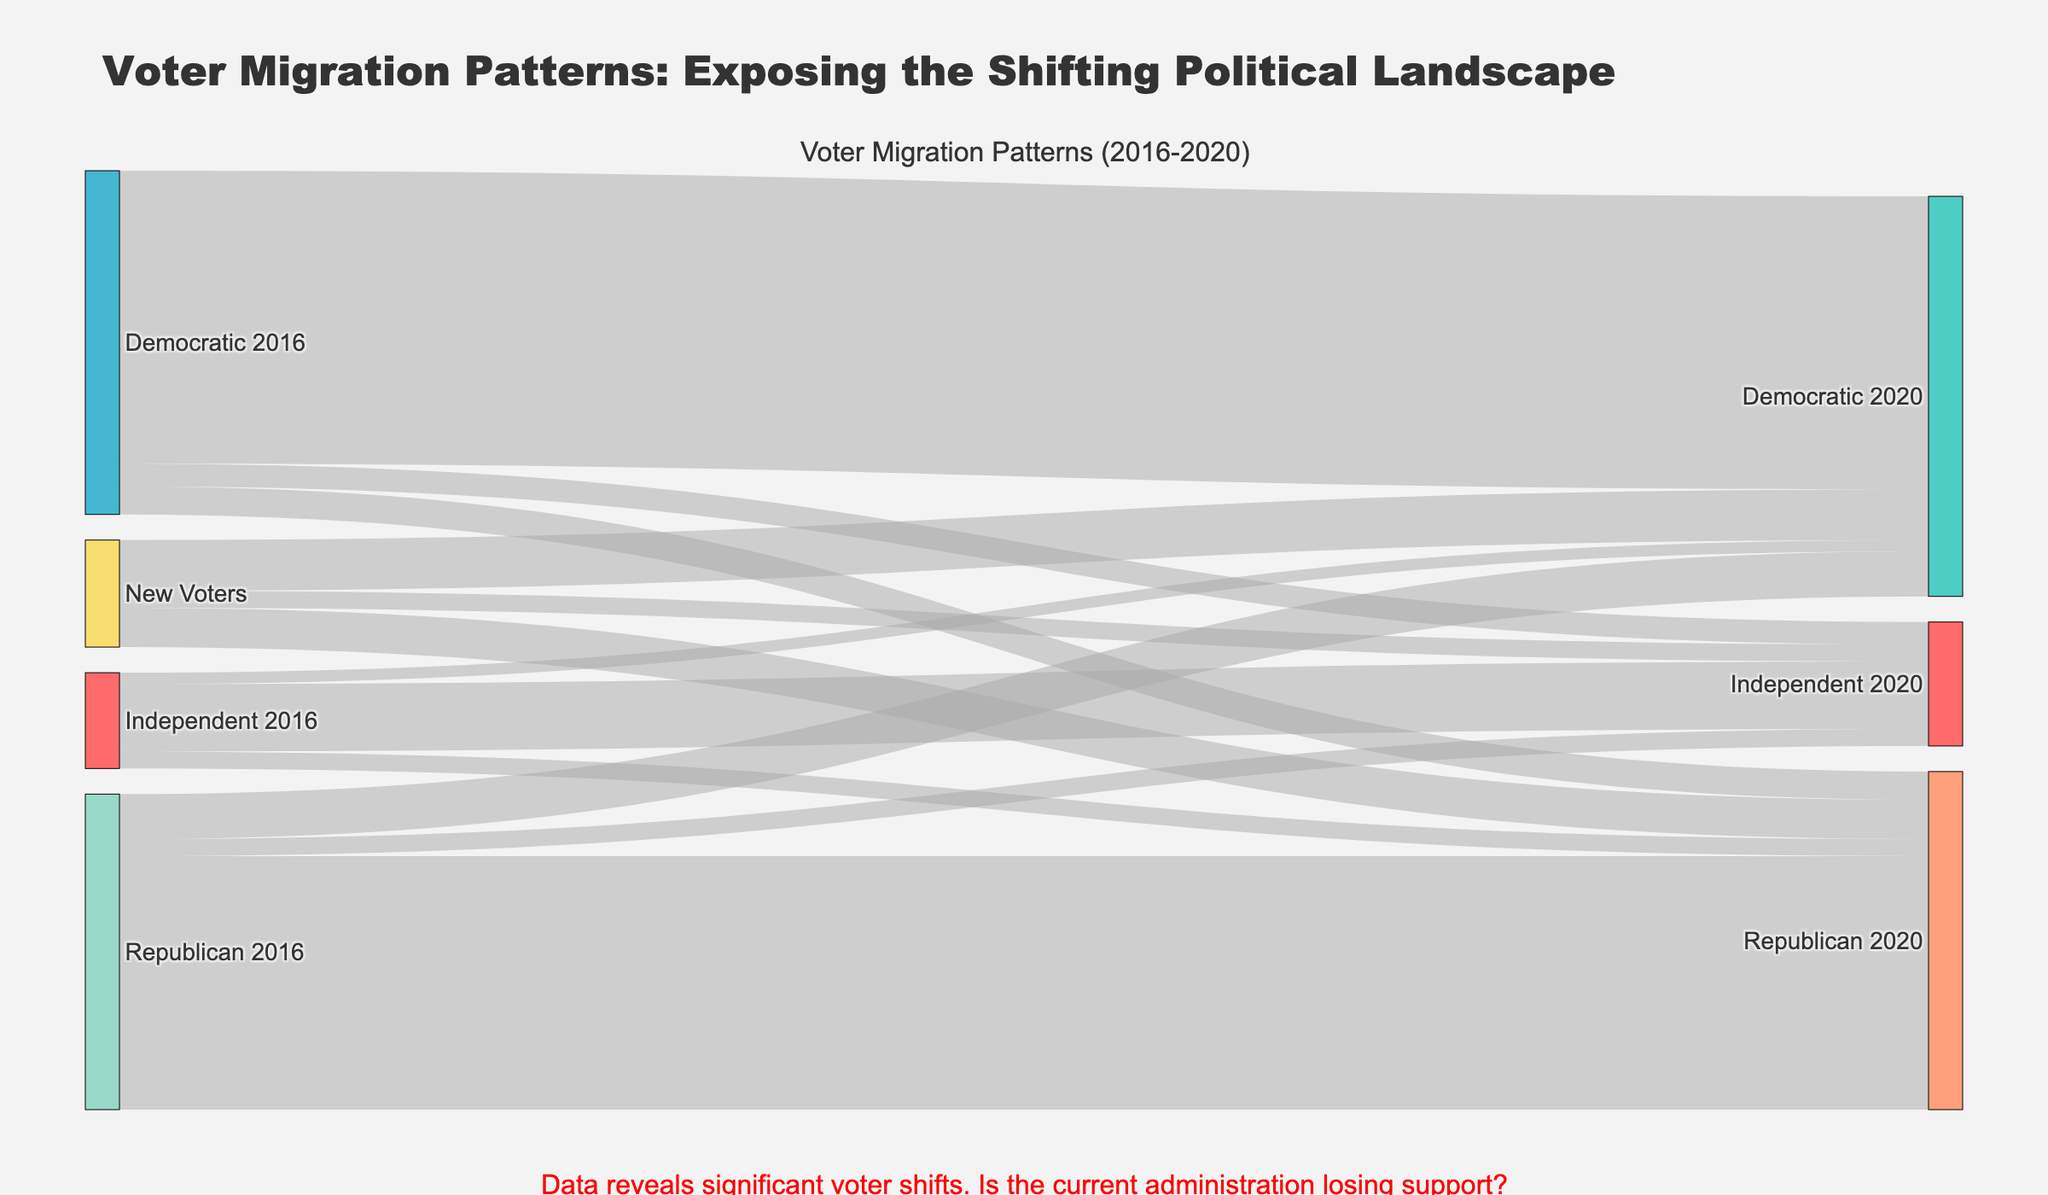What is the most common voter migration pattern? The figure shows the lines indicating voter migration patterns between parties. The thickest line, representing the highest number of voters, moves from Democratic 2016 to Democratic 2020.
Answer: Democratic 2016 to Democratic 2020 How many voters migrated from Independent 2016 to Republican 2020? By observing the figure, identify the line connecting Independent 2016 to Republican 2020 and read the associated value.
Answer: 3,000 Which party had the highest number of new voters in 2020? Look at the lines coming from the "New Voters" node and identify which target node has the highest value associated with it. The Democratic 2020 node has the most significant inflow of new voters.
Answer: Democratic 2020 What is the total number of voters who shifted away from the Republican party from 2016 to 2020? Sum the voter values migrating from Republican 2016 to other parties in 2020: 8,000 to Democratic 2020 and 3,000 to Independent 2020.
Answer: 11,000 How many voters switched parties from Democratic 2016 to Republican 2020? Identify the line connecting Democratic 2016 to Republican 2020 and read the associated value.
Answer: 5,000 What is the total number of voters who stayed with their respective parties from 2016 to 2020? Sum the values of voters who did not change parties: Republican 2016 to Republican 2020 (45,000), Democratic 2016 to Democratic 2020 (52,000), and Independent 2016 to Independent 2020 (12,000).
Answer: 109,000 Which party experienced the most significant voter loss from 2016 to 2020? Calculate the differences between the 2016 and 2020 values for each party and compare them. The Independent party saw a notable decrease, losing more voters than it gained.
Answer: Independent What percentage of Democratic 2016 voters remained loyal to the Democratic party in 2020? Divide the number of Democratic 2016 voters who stayed with the party (52,000) by the total Democratic 2016 voters (52,000 + 5,000 + 4,000) and multiply by 100.
Answer: 86.67% How many voters migrated from Democratic or Republican 2016 to Independent 2020? Sum the voters who moved from Democratic 2016 (4,000) and Republican 2016 (3,000) to Independent 2020.
Answer: 7,000 Which voter migration pattern had the smallest flow value? Identify the thinnest line in the diagram and its associated value. The smallest value corresponds to the migration from Independent 2016 to Democratic 2020.
Answer: Independent 2016 to Democratic 2020 